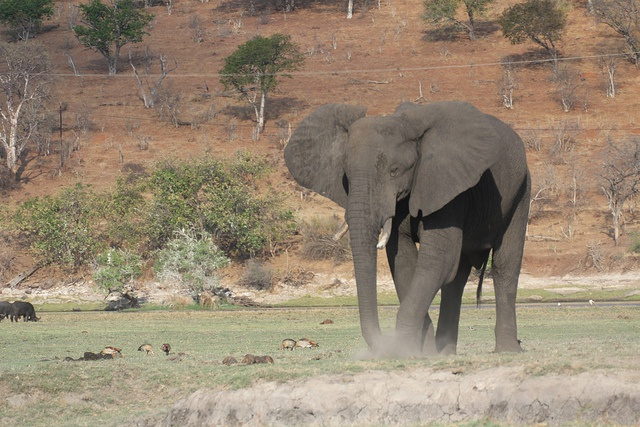Describe the objects in this image and their specific colors. I can see a elephant in black, gray, and darkgray tones in this image. 